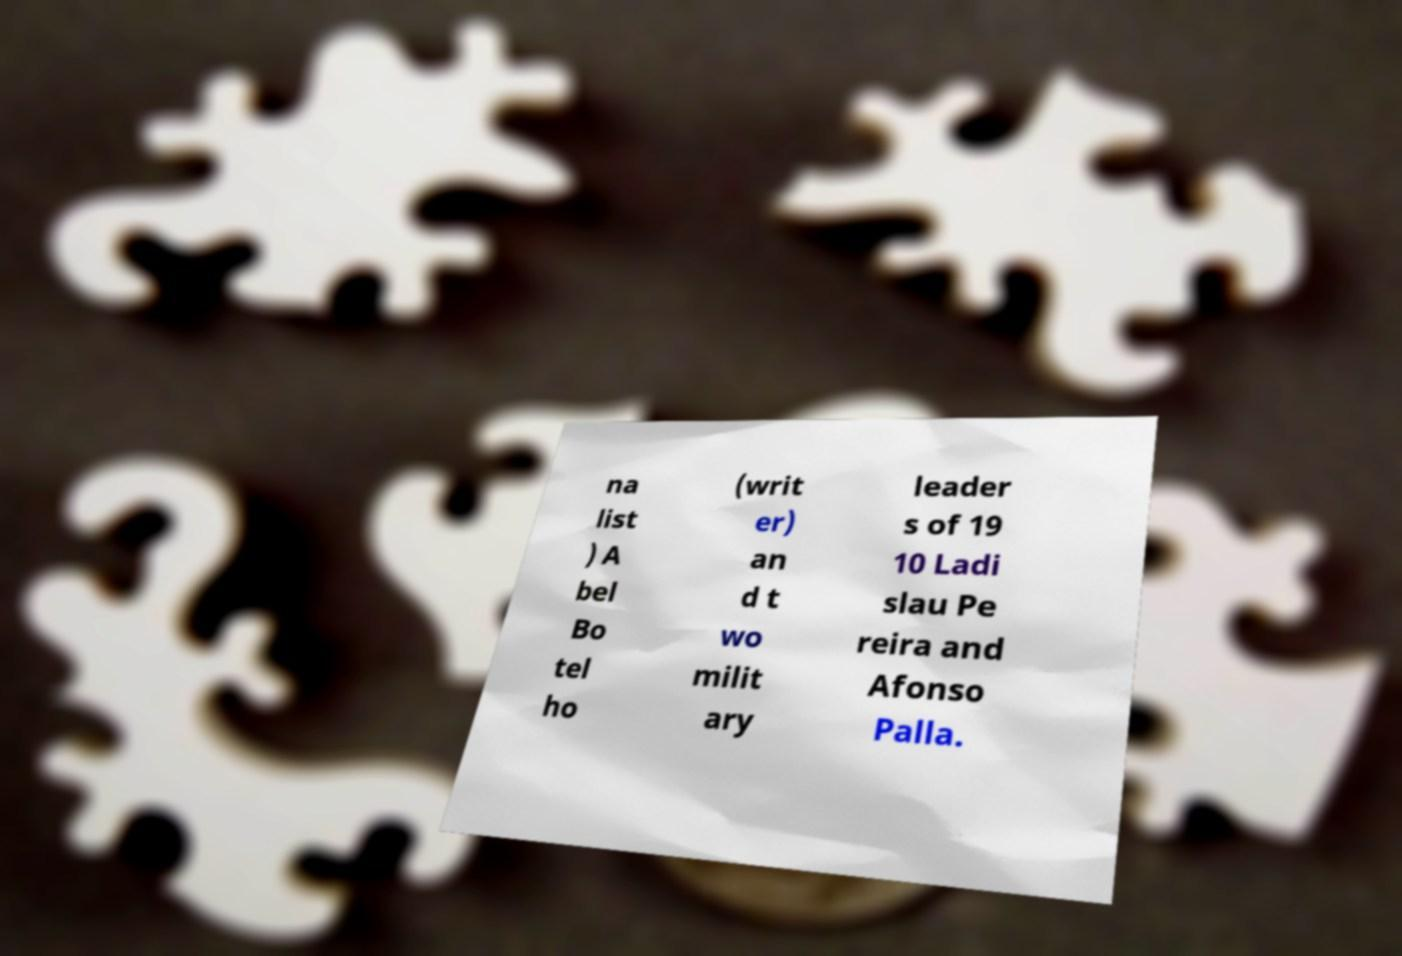Could you extract and type out the text from this image? na list ) A bel Bo tel ho (writ er) an d t wo milit ary leader s of 19 10 Ladi slau Pe reira and Afonso Palla. 